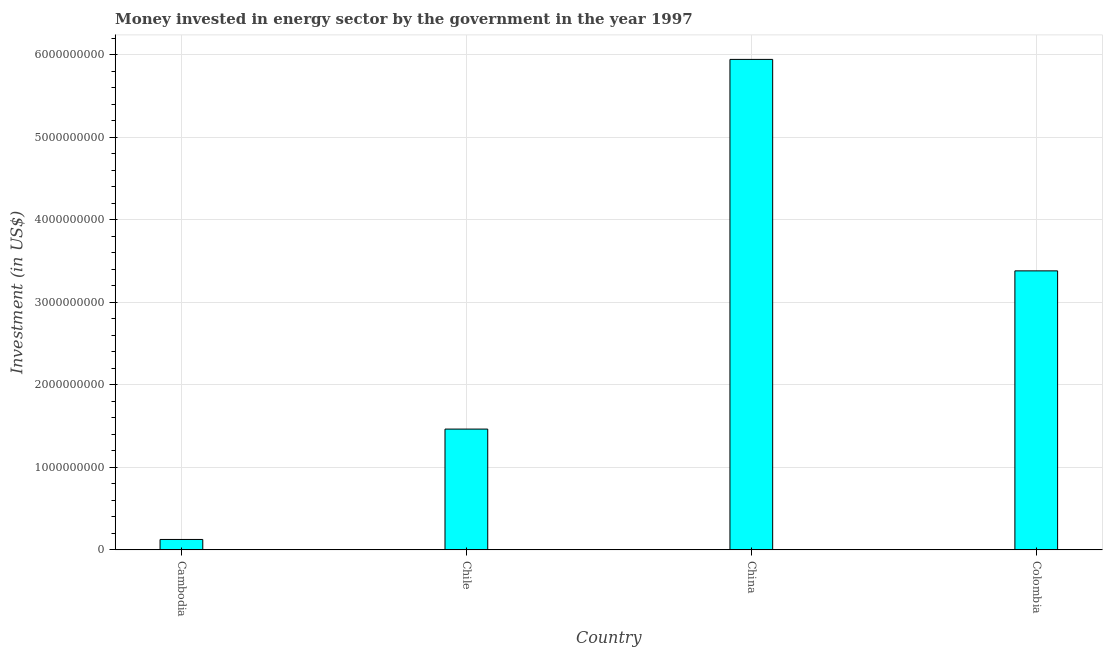Does the graph contain any zero values?
Ensure brevity in your answer.  No. What is the title of the graph?
Provide a short and direct response. Money invested in energy sector by the government in the year 1997. What is the label or title of the Y-axis?
Your answer should be compact. Investment (in US$). What is the investment in energy in Colombia?
Offer a very short reply. 3.38e+09. Across all countries, what is the maximum investment in energy?
Provide a short and direct response. 5.95e+09. Across all countries, what is the minimum investment in energy?
Give a very brief answer. 1.27e+08. In which country was the investment in energy maximum?
Your answer should be very brief. China. In which country was the investment in energy minimum?
Offer a terse response. Cambodia. What is the sum of the investment in energy?
Provide a short and direct response. 1.09e+1. What is the difference between the investment in energy in Chile and China?
Keep it short and to the point. -4.48e+09. What is the average investment in energy per country?
Your response must be concise. 2.73e+09. What is the median investment in energy?
Your answer should be compact. 2.42e+09. What is the ratio of the investment in energy in Chile to that in China?
Ensure brevity in your answer.  0.25. Is the investment in energy in Cambodia less than that in China?
Give a very brief answer. Yes. What is the difference between the highest and the second highest investment in energy?
Ensure brevity in your answer.  2.56e+09. What is the difference between the highest and the lowest investment in energy?
Provide a short and direct response. 5.82e+09. In how many countries, is the investment in energy greater than the average investment in energy taken over all countries?
Your answer should be compact. 2. How many bars are there?
Your answer should be compact. 4. Are all the bars in the graph horizontal?
Ensure brevity in your answer.  No. How many countries are there in the graph?
Ensure brevity in your answer.  4. Are the values on the major ticks of Y-axis written in scientific E-notation?
Offer a terse response. No. What is the Investment (in US$) of Cambodia?
Provide a succinct answer. 1.27e+08. What is the Investment (in US$) of Chile?
Ensure brevity in your answer.  1.46e+09. What is the Investment (in US$) in China?
Provide a succinct answer. 5.95e+09. What is the Investment (in US$) in Colombia?
Offer a terse response. 3.38e+09. What is the difference between the Investment (in US$) in Cambodia and Chile?
Your answer should be very brief. -1.34e+09. What is the difference between the Investment (in US$) in Cambodia and China?
Your response must be concise. -5.82e+09. What is the difference between the Investment (in US$) in Cambodia and Colombia?
Offer a terse response. -3.26e+09. What is the difference between the Investment (in US$) in Chile and China?
Your response must be concise. -4.48e+09. What is the difference between the Investment (in US$) in Chile and Colombia?
Make the answer very short. -1.92e+09. What is the difference between the Investment (in US$) in China and Colombia?
Ensure brevity in your answer.  2.56e+09. What is the ratio of the Investment (in US$) in Cambodia to that in Chile?
Your answer should be compact. 0.09. What is the ratio of the Investment (in US$) in Cambodia to that in China?
Provide a short and direct response. 0.02. What is the ratio of the Investment (in US$) in Cambodia to that in Colombia?
Offer a terse response. 0.04. What is the ratio of the Investment (in US$) in Chile to that in China?
Ensure brevity in your answer.  0.25. What is the ratio of the Investment (in US$) in Chile to that in Colombia?
Offer a very short reply. 0.43. What is the ratio of the Investment (in US$) in China to that in Colombia?
Your answer should be compact. 1.76. 